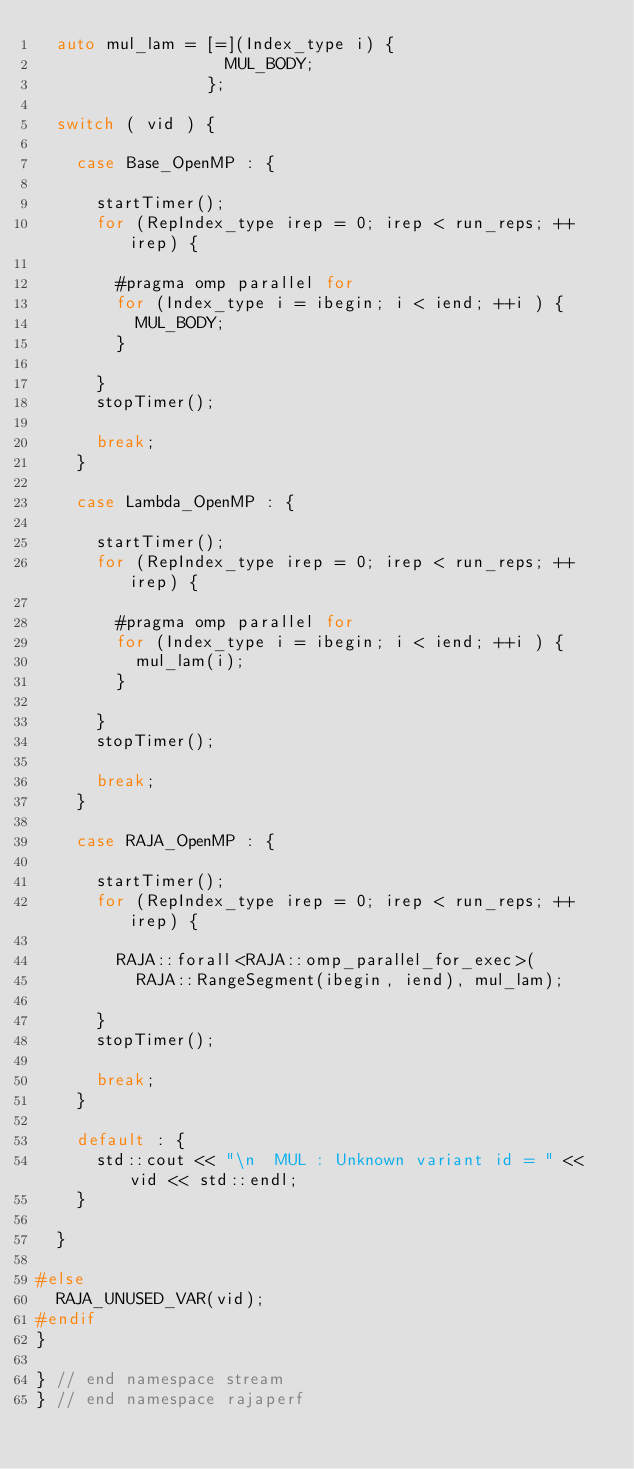Convert code to text. <code><loc_0><loc_0><loc_500><loc_500><_C++_>  auto mul_lam = [=](Index_type i) {
                   MUL_BODY;
                 };

  switch ( vid ) {

    case Base_OpenMP : {

      startTimer();
      for (RepIndex_type irep = 0; irep < run_reps; ++irep) {

        #pragma omp parallel for
        for (Index_type i = ibegin; i < iend; ++i ) {
          MUL_BODY;
        }

      }
      stopTimer();

      break;
    }

    case Lambda_OpenMP : {

      startTimer();
      for (RepIndex_type irep = 0; irep < run_reps; ++irep) {

        #pragma omp parallel for
        for (Index_type i = ibegin; i < iend; ++i ) {
          mul_lam(i);
        }

      }
      stopTimer();

      break;
    }

    case RAJA_OpenMP : {

      startTimer();
      for (RepIndex_type irep = 0; irep < run_reps; ++irep) {

        RAJA::forall<RAJA::omp_parallel_for_exec>(
          RAJA::RangeSegment(ibegin, iend), mul_lam);

      }
      stopTimer();

      break;
    }

    default : {
      std::cout << "\n  MUL : Unknown variant id = " << vid << std::endl;
    }

  }

#else 
  RAJA_UNUSED_VAR(vid);
#endif
}

} // end namespace stream
} // end namespace rajaperf
</code> 